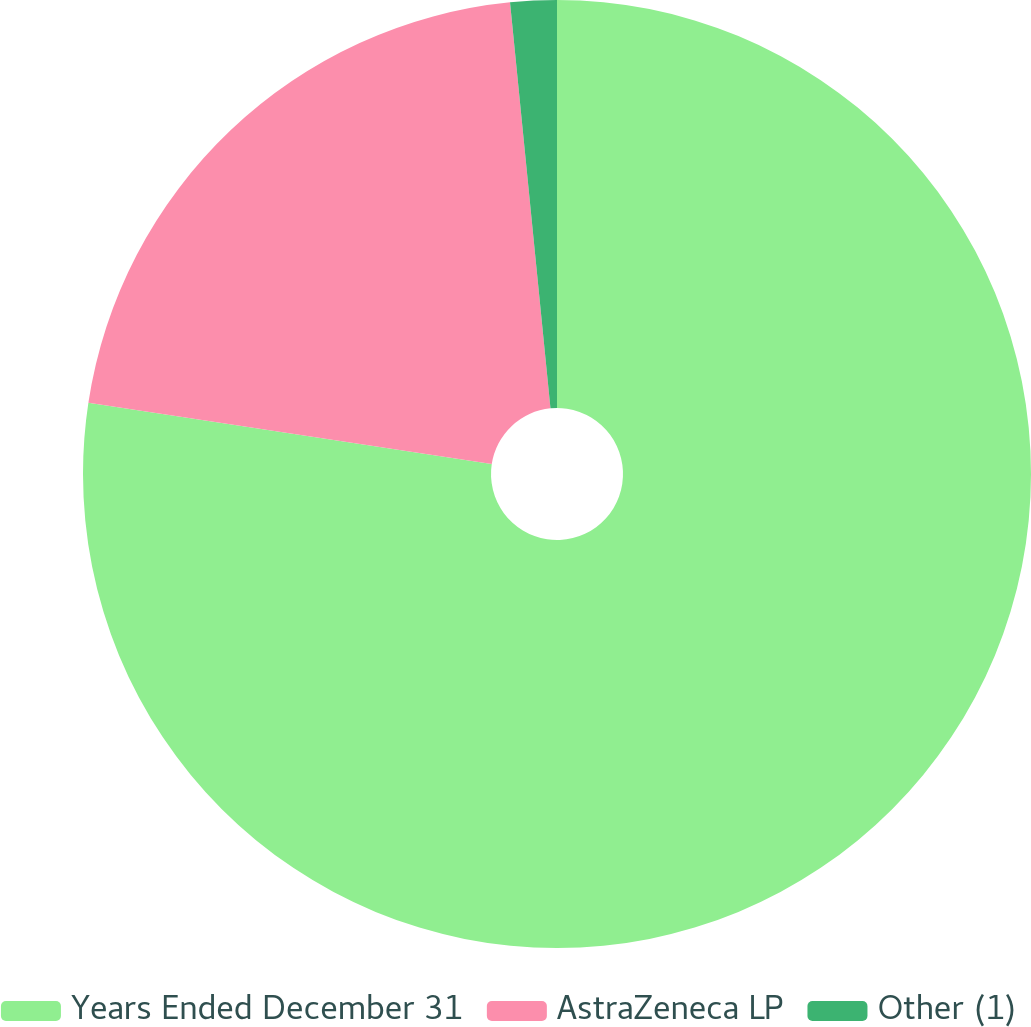Convert chart. <chart><loc_0><loc_0><loc_500><loc_500><pie_chart><fcel>Years Ended December 31<fcel>AstraZeneca LP<fcel>Other (1)<nl><fcel>77.4%<fcel>21.02%<fcel>1.58%<nl></chart> 